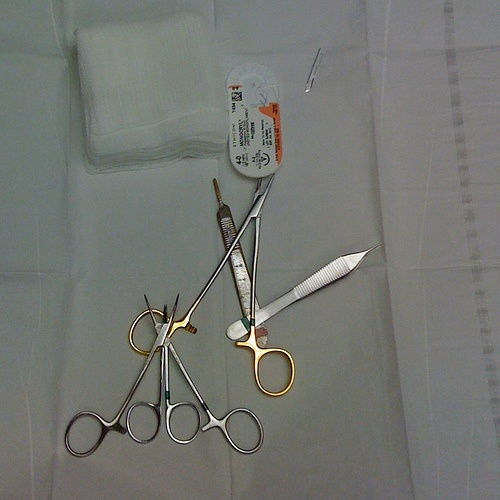Describe the objects in this image and their specific colors. I can see scissors in gray, black, ivory, and darkgray tones, scissors in gray, black, and darkgray tones, and scissors in gray, black, lightgray, and darkgray tones in this image. 